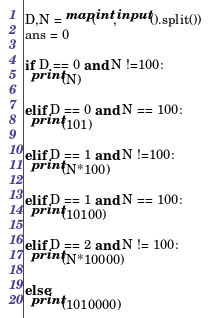<code> <loc_0><loc_0><loc_500><loc_500><_Python_>D,N = map(int,input().split())
ans = 0

if D == 0 and N !=100:
  print(N)
  
elif D == 0 and N == 100:
  print(101)
  
elif D == 1 and N !=100:
  print(N*100)
  
elif D == 1 and N == 100:
  print(10100)
  
elif D == 2 and N != 100:
  print(N*10000)
  
else:
  print(1010000)</code> 